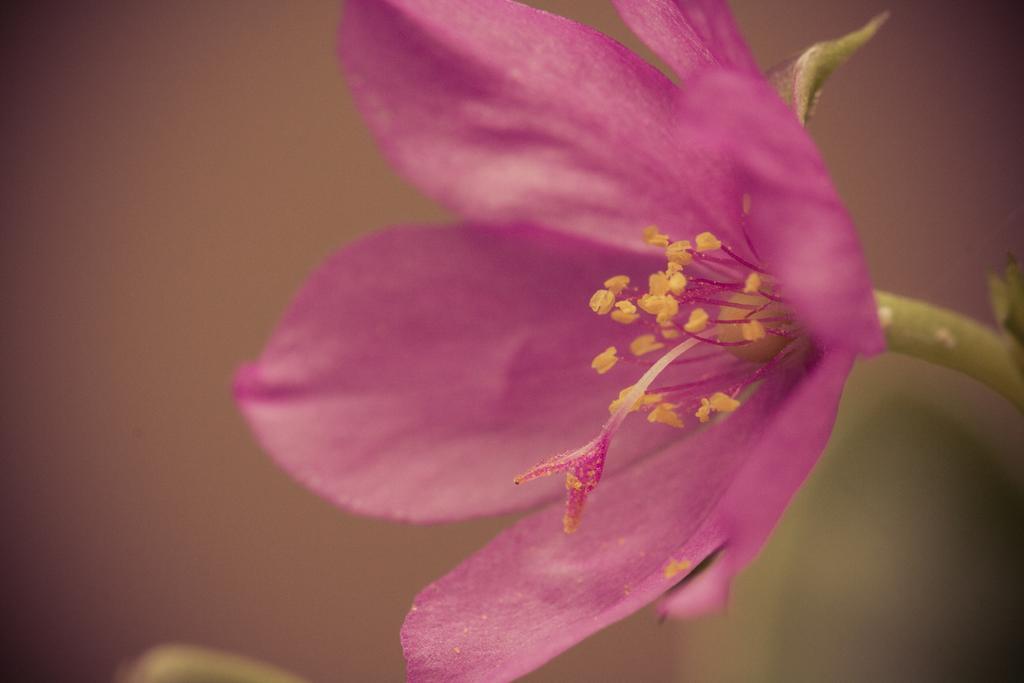Could you give a brief overview of what you see in this image? In this picture I can see a flow to the stem. 